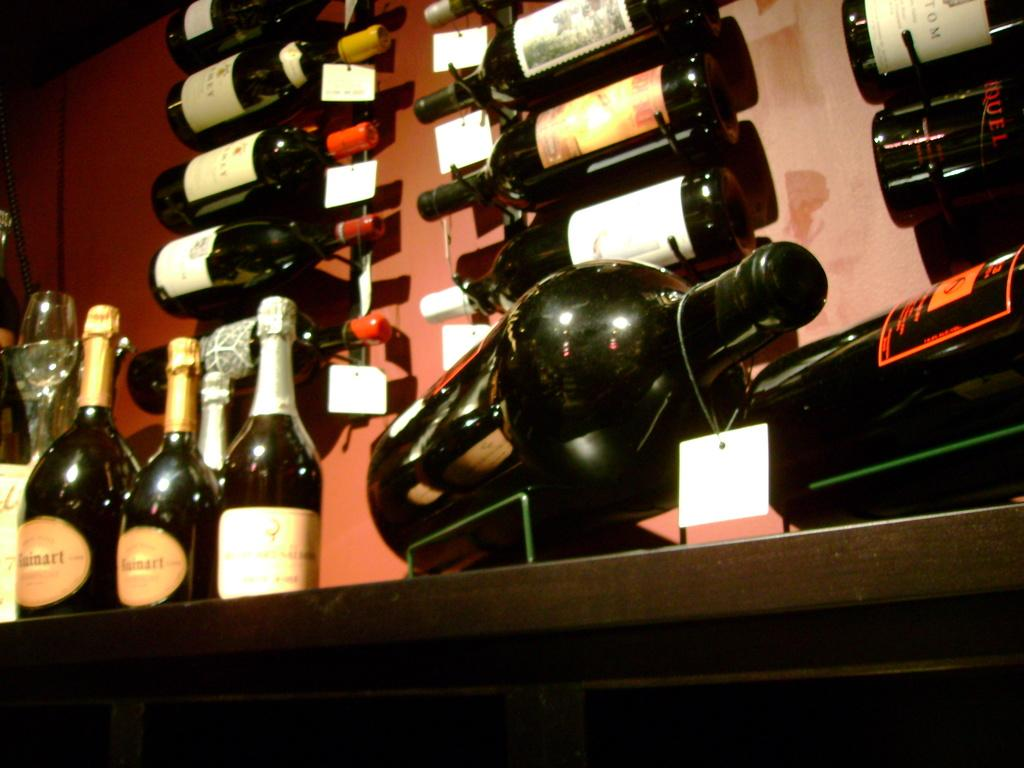What objects are present in the image that are typically used for holding liquids? There are bottles in the image. What additional information can be gathered about the bottles? There are tags on the bottles. What can be seen on the left side of the image? There is a glass on the left side of the image. What is visible in the background of the image? There is a wall in the background of the image. How many men are playing with balls in the image? There are no men or balls present in the image. 